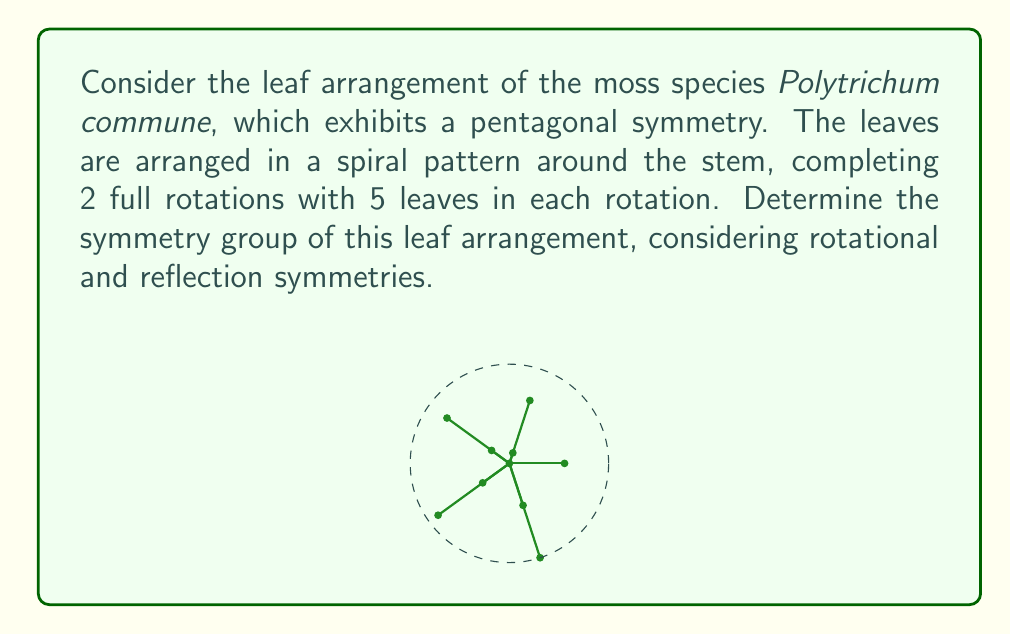Solve this math problem. To determine the symmetry group of the moss leaf arrangement, we need to consider both rotational and reflection symmetries:

1. Rotational symmetry:
   - The leaf arrangement completes 2 full rotations with 5 leaves in each rotation.
   - This means we have rotational symmetry of order 5.
   - The rotations are: $\{e, r, r^2, r^3, r^4\}$, where $e$ is the identity and $r$ is a rotation by $2\pi/5$.

2. Reflection symmetry:
   - There are 5 lines of reflection, each passing through a leaf and the center of the arrangement.
   - Let's denote these reflections as $\{s_1, s_2, s_3, s_4, s_5\}$.

3. Group structure:
   - The set of symmetries forms a group under composition.
   - This group contains 10 elements: 5 rotations and 5 reflections.
   - The group operation table follows the structure of the dihedral group $D_5$.

4. Properties of $D_5$:
   - $D_5$ is non-abelian, as rotations and reflections don't always commute.
   - It has order 10.
   - It is generated by two elements: $r$ (rotation by $2\pi/5$) and $s$ (any reflection).

5. Isomorphism:
   - The symmetry group of the moss leaf arrangement is isomorphic to $D_5$.

Therefore, the symmetry group of the Polytrichum commune leaf arrangement is the dihedral group $D_5$.
Answer: $D_5$ 